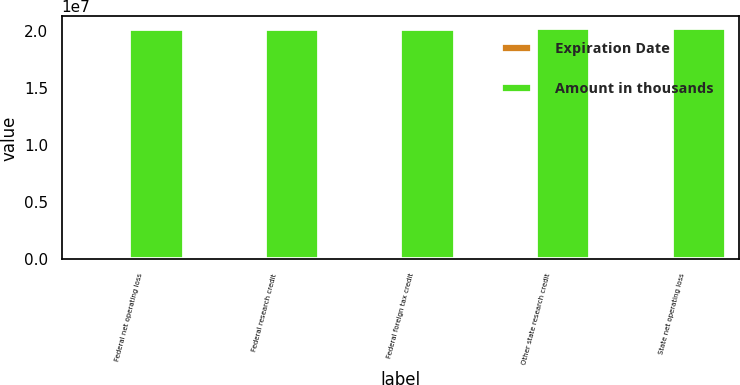Convert chart to OTSL. <chart><loc_0><loc_0><loc_500><loc_500><stacked_bar_chart><ecel><fcel>Federal net operating loss<fcel>Federal research credit<fcel>Federal foreign tax credit<fcel>Other state research credit<fcel>State net operating loss<nl><fcel>Expiration Date<fcel>139526<fcel>109760<fcel>2427<fcel>10873<fcel>104174<nl><fcel>Amount in thousands<fcel>2.0192e+07<fcel>2.0192e+07<fcel>2.0192e+07<fcel>2.0232e+07<fcel>2.0242e+07<nl></chart> 